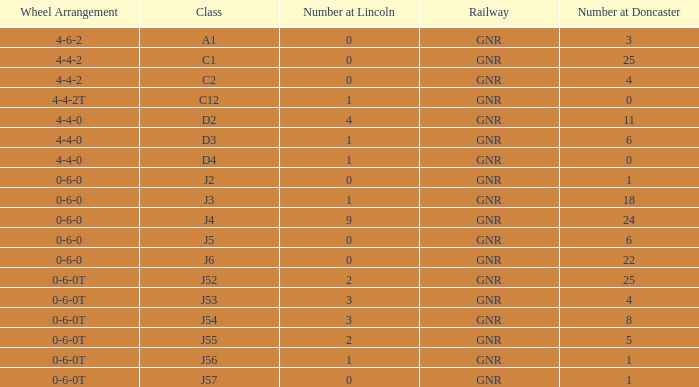Which Class has a Number at Lincoln larger than 0 and a Number at Doncaster of 8? J54. 